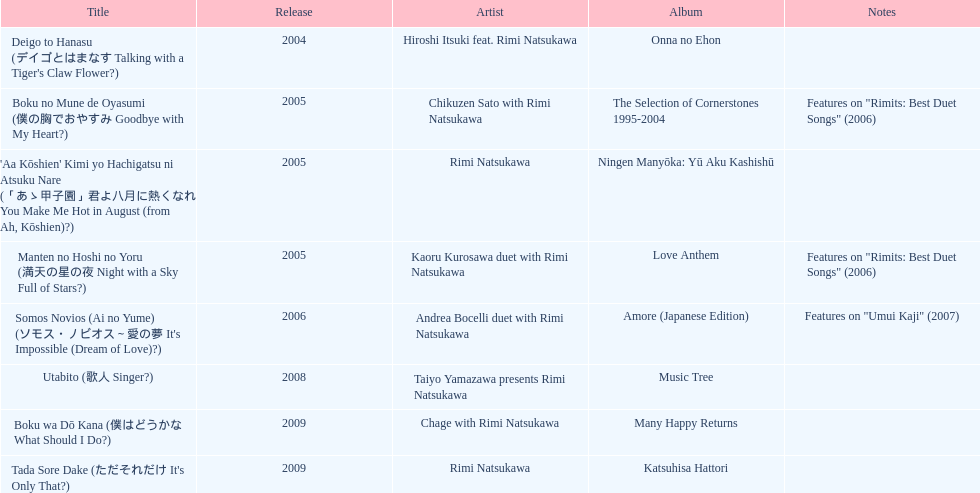Which title has the same notes as night with a sky full of stars? Boku no Mune de Oyasumi (僕の胸でおやすみ Goodbye with My Heart?). 